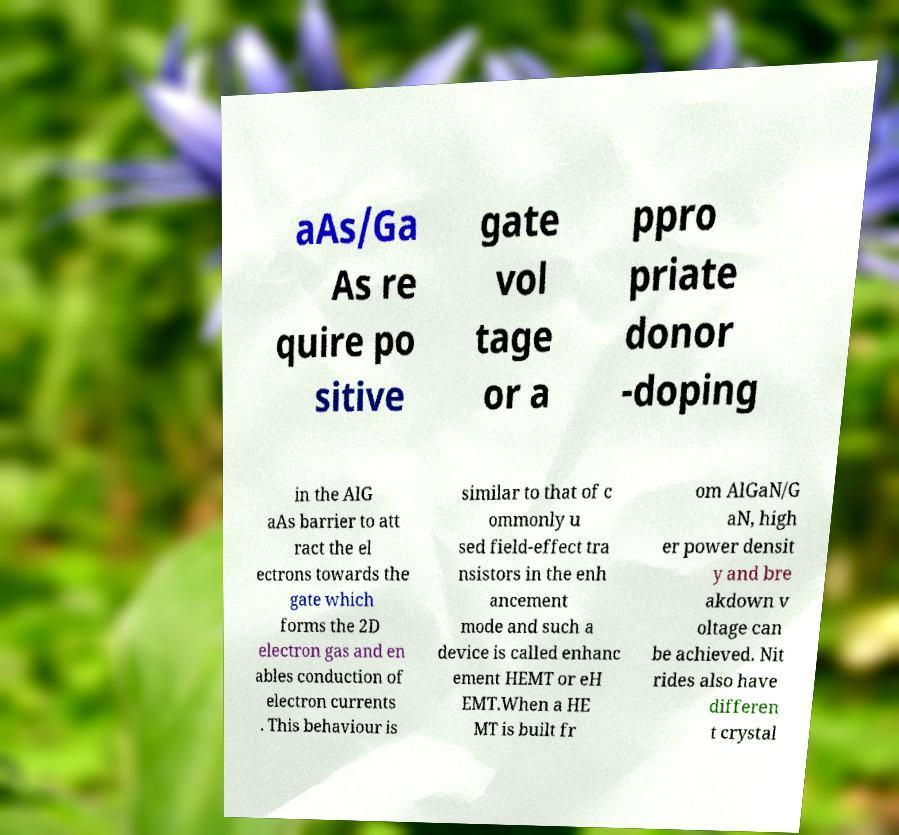Could you extract and type out the text from this image? aAs/Ga As re quire po sitive gate vol tage or a ppro priate donor -doping in the AlG aAs barrier to att ract the el ectrons towards the gate which forms the 2D electron gas and en ables conduction of electron currents . This behaviour is similar to that of c ommonly u sed field-effect tra nsistors in the enh ancement mode and such a device is called enhanc ement HEMT or eH EMT.When a HE MT is built fr om AlGaN/G aN, high er power densit y and bre akdown v oltage can be achieved. Nit rides also have differen t crystal 